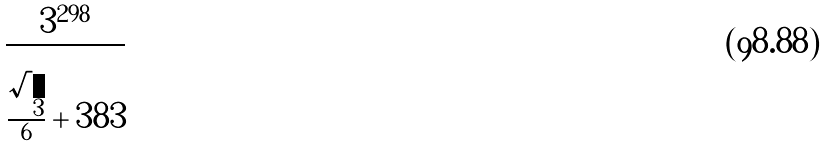<formula> <loc_0><loc_0><loc_500><loc_500>\frac { 3 ^ { 2 9 8 } } { \frac { \sqrt { 3 } } { 6 } + 3 8 3 }</formula> 